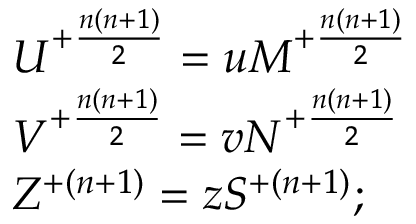<formula> <loc_0><loc_0><loc_500><loc_500>\begin{array} { l c r } { { U ^ { + { \frac { n ( n + 1 ) } { 2 } } } = u M ^ { + { \frac { n ( n + 1 ) } { 2 } } } } } \\ { { V ^ { + { \frac { n ( n + 1 ) } { 2 } } } = v N ^ { + { \frac { n ( n + 1 ) } { 2 } } } } } \\ { { Z ^ { + { ( n + 1 ) } } = z S ^ { + { ( n + 1 ) } } ; } } \end{array}</formula> 